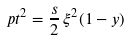<formula> <loc_0><loc_0><loc_500><loc_500>\ p t ^ { 2 } = \frac { s } { 2 } \, \xi ^ { 2 } ( 1 - y )</formula> 